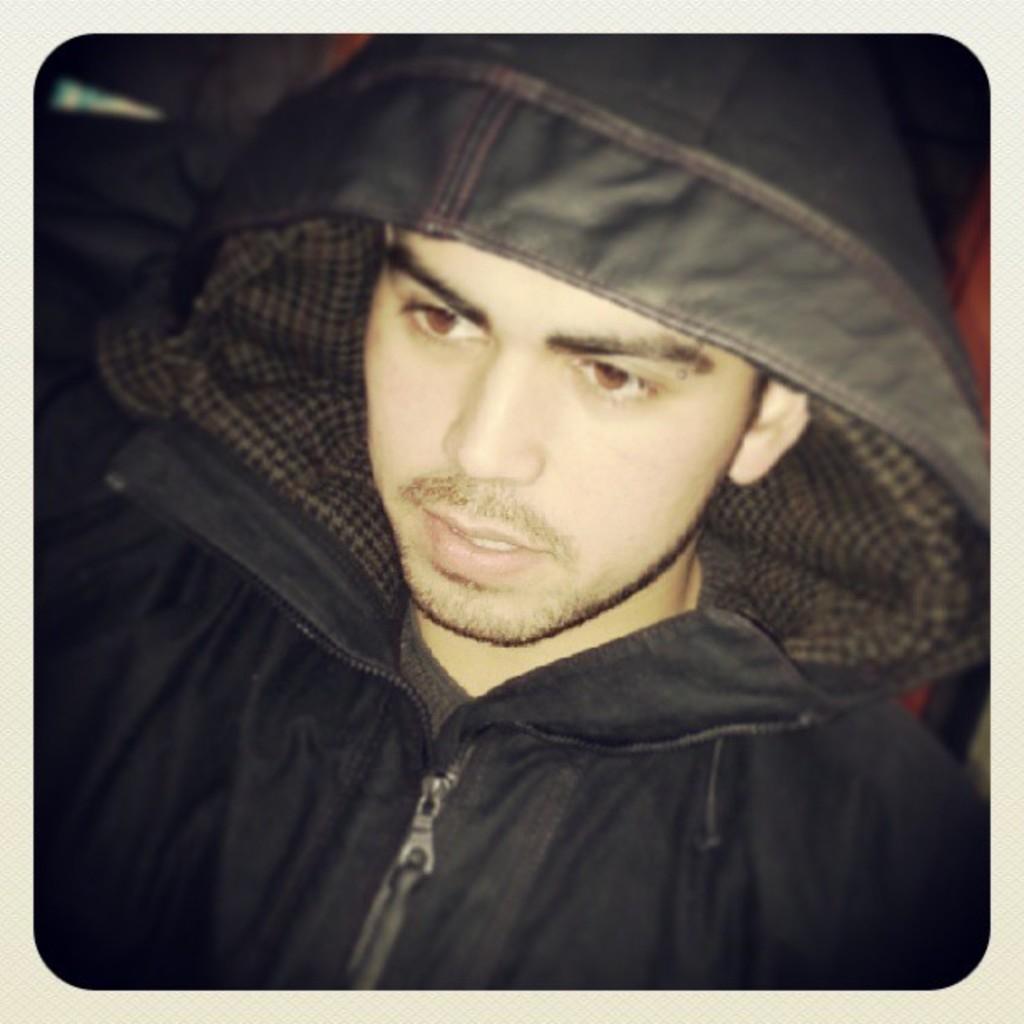Can you describe this image briefly? In the center of the image we can see a man wearing a jacket. 